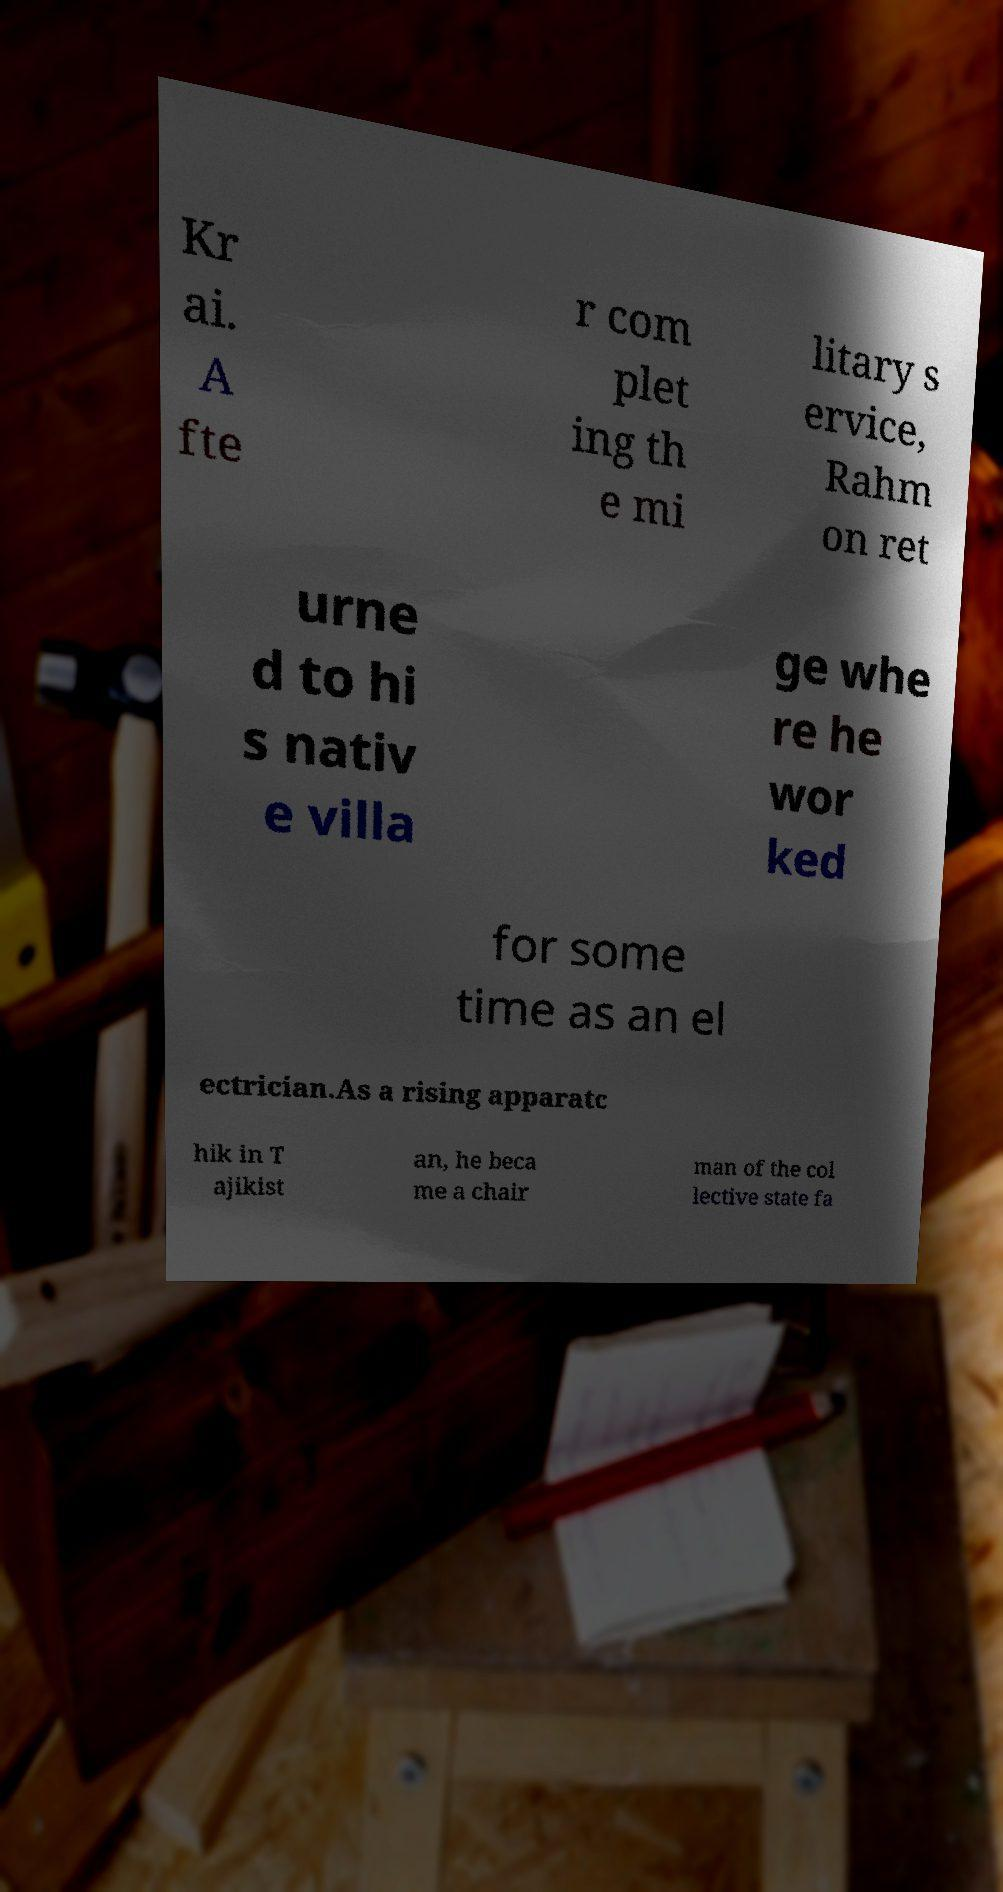I need the written content from this picture converted into text. Can you do that? Kr ai. A fte r com plet ing th e mi litary s ervice, Rahm on ret urne d to hi s nativ e villa ge whe re he wor ked for some time as an el ectrician.As a rising apparatc hik in T ajikist an, he beca me a chair man of the col lective state fa 